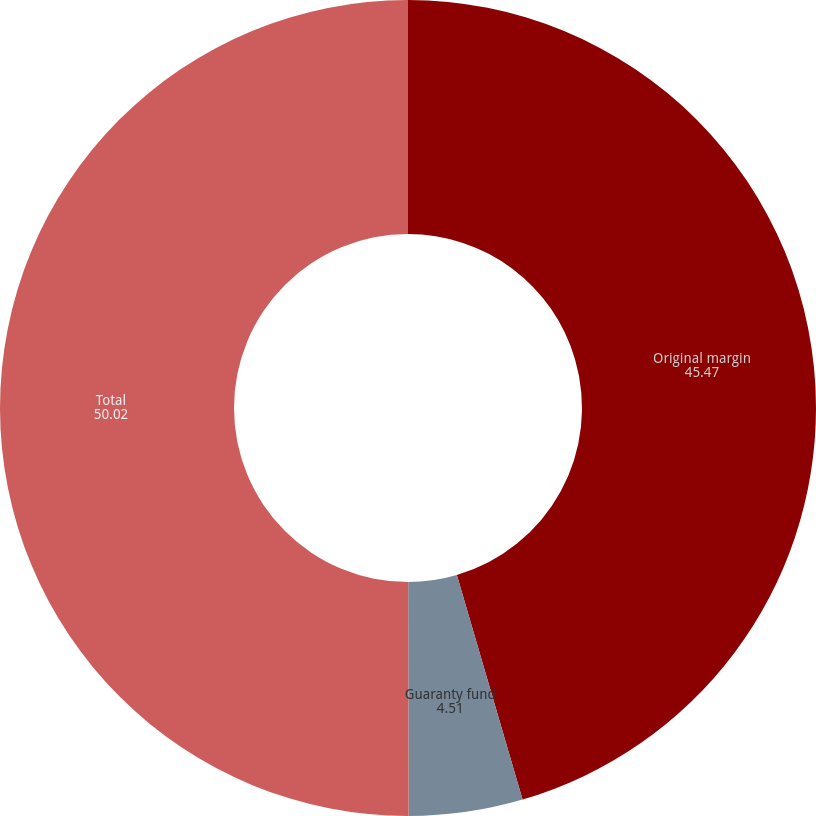<chart> <loc_0><loc_0><loc_500><loc_500><pie_chart><fcel>Original margin<fcel>Guaranty fund<fcel>Total<nl><fcel>45.47%<fcel>4.51%<fcel>50.02%<nl></chart> 